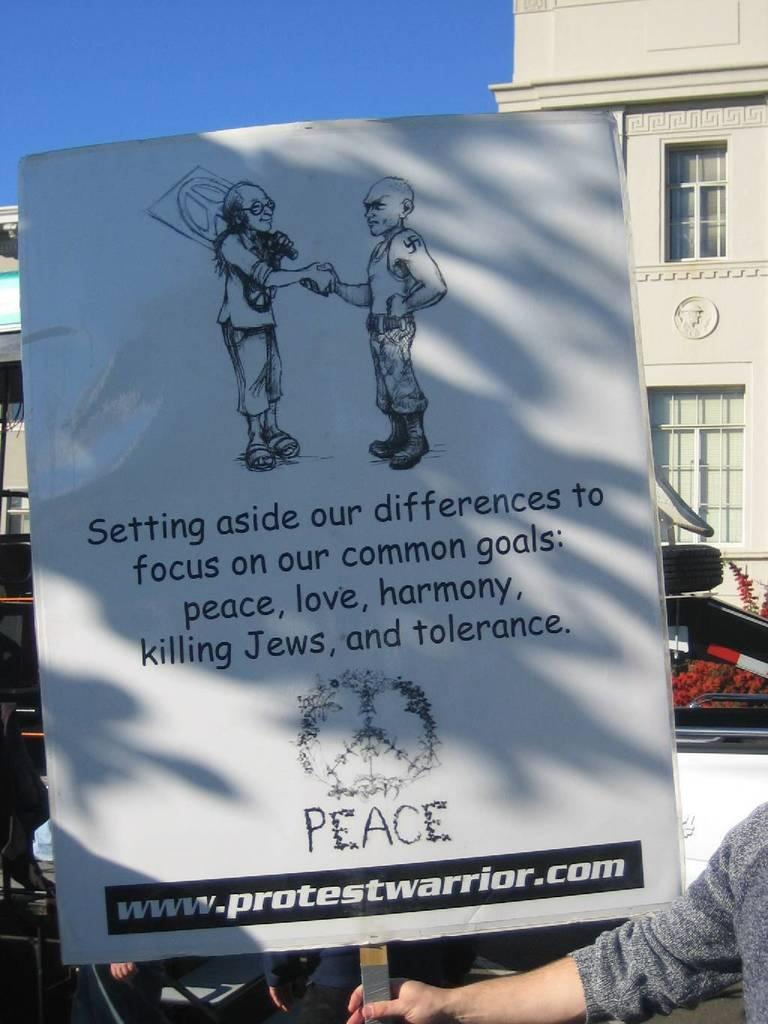What is the person in the image holding? The person is holding a board. What can be seen in the background of the image? There is a building with windows in the background. What color is the sky in the image? The sky is blue in the image. What type of cork can be seen on the person's shoes in the image? There is no cork visible on the person's shoes in the image. What animal is present in the image? There are no animals present in the image. 